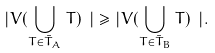Convert formula to latex. <formula><loc_0><loc_0><loc_500><loc_500>| V ( \bigcup _ { T \in \bar { T } _ { A } } T ) \ | \geq | V ( \bigcup _ { T \in \bar { T } _ { B } } T ) \ | .</formula> 